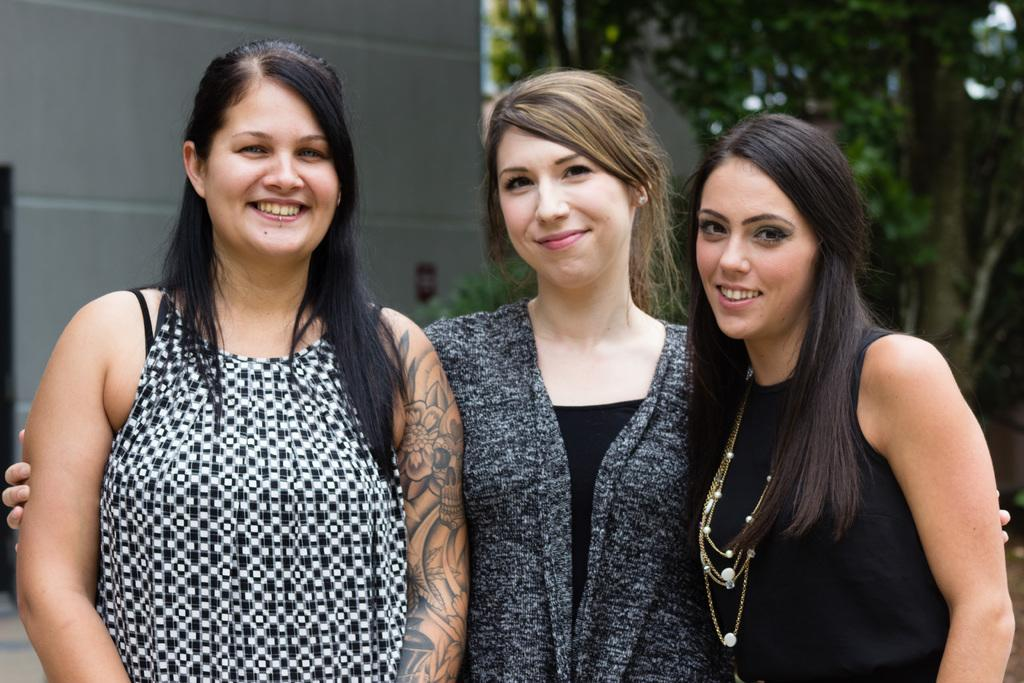How many people are in the image? There are three persons in the image. What are the persons doing in the image? The persons are standing and smiling. What can be seen in the background of the image? There are trees and a wall in the background of the image. What type of meat can be seen hanging from the wall in the image? There is no meat present in the image; the wall is in the background and does not have any meat hanging from it. 